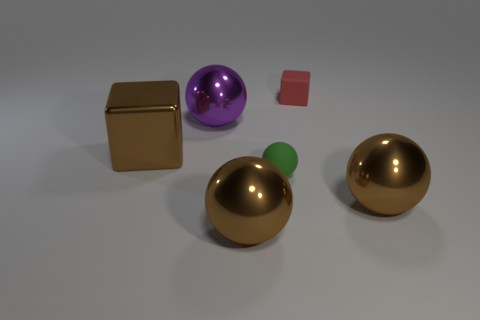Which object stands out the most and why? The large, shiny golden sphere draws the most attention due to its reflective surface and prominent size in contrast to the other objects. What can you tell me about the lighting in the image? The lighting in the image is soft and diffused, casting gentle shadows and reflecting subtly off the metallic surfaces, particularly the gold spheres and cube. 